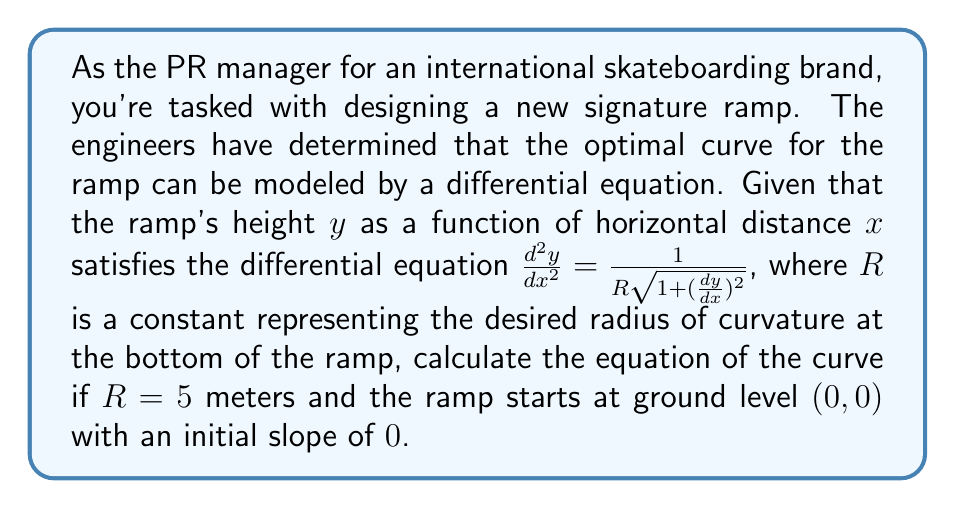Help me with this question. To solve this problem, we'll follow these steps:

1) First, let's simplify the notation by setting $y' = \frac{dy}{dx}$ and $y'' = \frac{d^2y}{dx^2}$. The differential equation becomes:

   $$y'' = \frac{1}{R\sqrt{1+(y')^2}}$$

2) Given $R = 5$, we have:

   $$y'' = \frac{1}{5\sqrt{1+(y')^2}}$$

3) To solve this, we can use the substitution $y' = \sinh(u)$. This is because $\frac{d}{dx}\sinh(u) = \cosh(u)\frac{du}{dx}$ and $1+\sinh^2(u) = \cosh^2(u)$.

4) With this substitution:

   $$y'' = \cosh(u)\frac{du}{dx} = \frac{1}{5\sqrt{1+\sinh^2(u)}} = \frac{1}{5\cosh(u)}$$

5) Simplifying:

   $$\cosh(u)\frac{du}{dx} = \frac{1}{5\cosh(u)}$$
   $$\cosh^2(u)du = \frac{1}{5}dx$$

6) Integrating both sides:

   $$\int \cosh^2(u)du = \frac{1}{5}\int dx$$
   $$\frac{1}{2}u + \frac{1}{4}\sinh(2u) = \frac{x}{5} + C_1$$

7) Remember that $y' = \sinh(u)$, so:

   $$y' = \sinh(\frac{2x}{5} + C_2)$$

8) Integrating again:

   $$y = -\frac{5}{2}\cosh(\frac{2x}{5} + C_2) + C_3$$

9) Now we use the initial conditions. At $x=0$, $y=0$, so:

   $$0 = -\frac{5}{2}\cosh(C_2) + C_3$$

10) Also, at $x=0$, $y'=0$, which means $\sinh(C_2) = 0$, so $C_2 = 0$.

11) From step 9, we can now conclude that $C_3 = \frac{5}{2}$.

12) Therefore, the final equation of the curve is:

    $$y = \frac{5}{2}(1 - \cosh(\frac{2x}{5}))$$

This equation represents the optimal curve for the skateboard ramp.
Answer: $y = \frac{5}{2}(1 - \cosh(\frac{2x}{5}))$ 